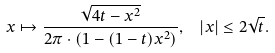Convert formula to latex. <formula><loc_0><loc_0><loc_500><loc_500>x \mapsto \frac { \sqrt { 4 t - x ^ { 2 } } } { 2 \pi \cdot ( 1 - ( 1 - t ) x ^ { 2 } ) } , \ \ | x | \leq 2 \sqrt { t } .</formula> 